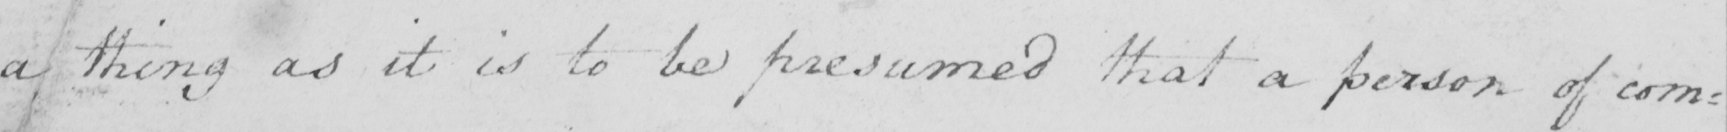Please provide the text content of this handwritten line. a thing as it is to be presumed that a person of com : 